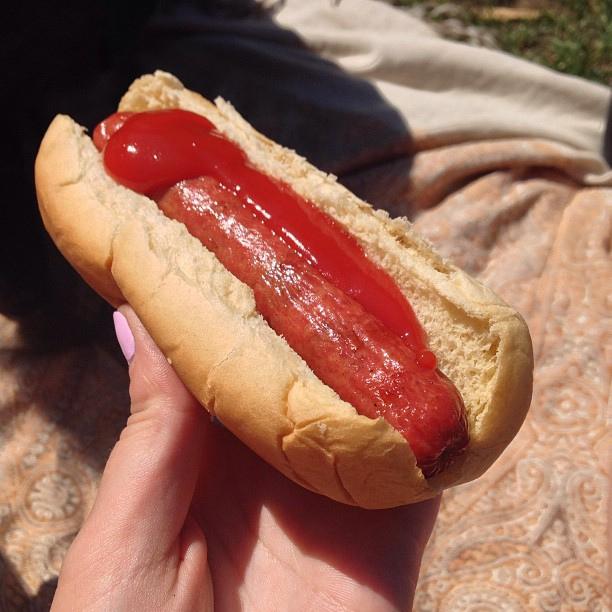Was the hot dog grilled?
Answer briefly. Yes. Is the bun grilled?
Answer briefly. No. What is the red stuff on the hot dog?
Concise answer only. Ketchup. What is the hot dog bun made out of?
Give a very brief answer. Bread. Is the bun longer than the hotdog?
Write a very short answer. No. Is it a man or woman holding the hot dog?
Be succinct. Woman. What is the shape of the ketchup on the hot dog?
Give a very brief answer. Line. Where was this taken?
Concise answer only. Outside. Does this person have long nails?
Be succinct. No. What condiment is on the hot dog?
Give a very brief answer. Ketchup. 